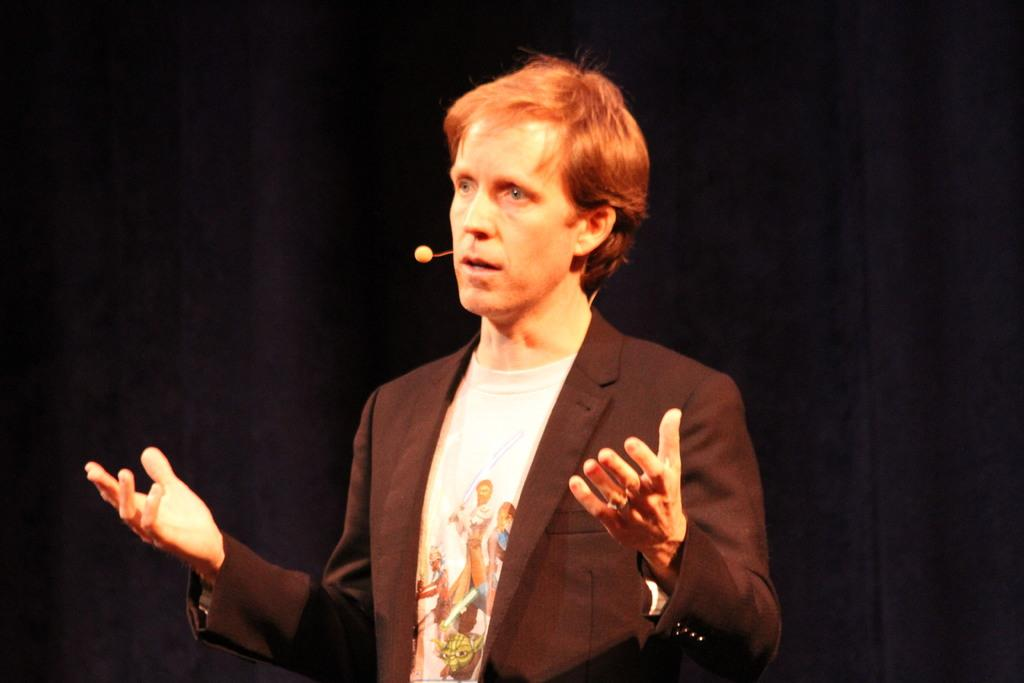What is the main subject of the image? There is a person standing in the image. What is the person doing in the image? The person is looking to the left side of the image. Can you describe the background of the image? The background of the image is blurry. How many cows are visible in the image? There are no cows present in the image. What type of ghost can be seen in the image? There is no ghost present in the image. 